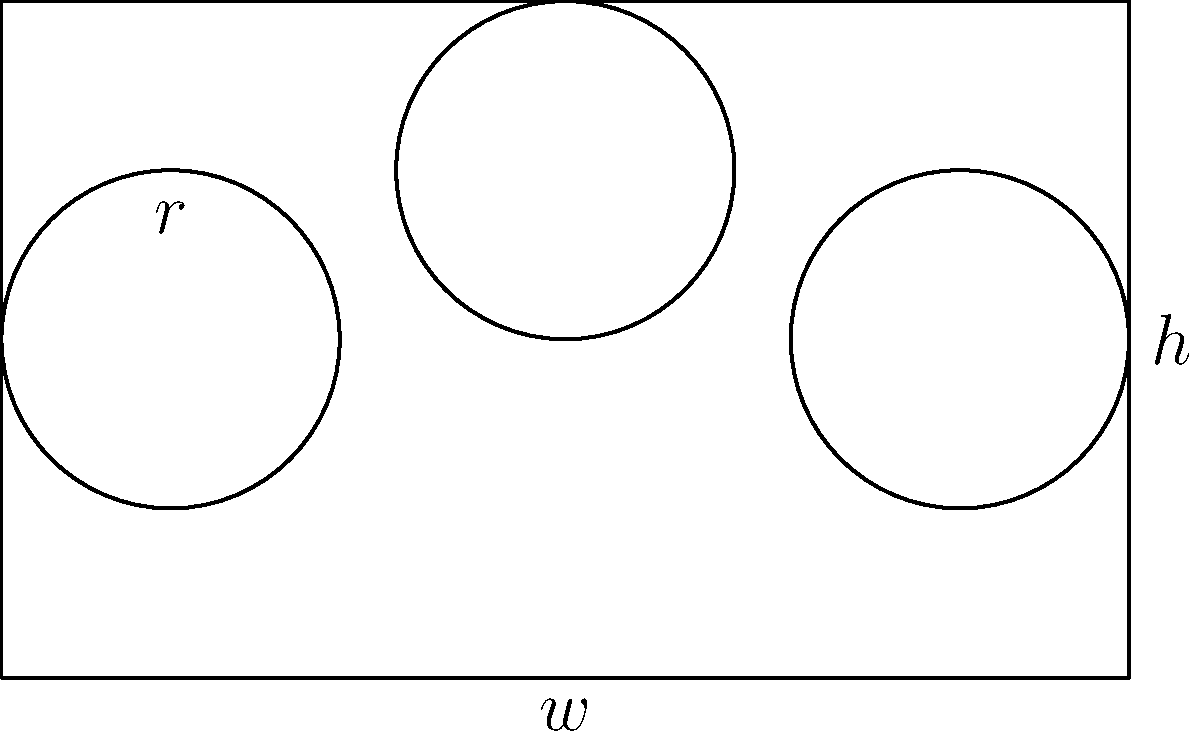As a member of the Fishwatcher Club, you're tasked with designing an aquarium wall with circular viewing windows. The rectangular wall has a width $w$ of 10 meters and a height $h$ of 6 meters. You want to install three identical circular windows with radius $r$ of 1.5 meters. Two windows should be placed at mid-height on the left and right sides of the wall, while the third should be centered horizontally at the top of the wall. What is the total viewing area provided by these windows as a percentage of the entire wall area? Round your answer to the nearest whole percent. Let's approach this step-by-step:

1) First, calculate the area of the rectangular wall:
   $A_{wall} = w \times h = 10 \text{ m} \times 6 \text{ m} = 60 \text{ m}^2$

2) Now, calculate the area of one circular window:
   $A_{window} = \pi r^2 = \pi \times (1.5 \text{ m})^2 = 2.25\pi \text{ m}^2$

3) There are three identical windows, so the total window area is:
   $A_{total\_windows} = 3 \times 2.25\pi \text{ m}^2 = 6.75\pi \text{ m}^2$

4) Convert this to a numerical value:
   $A_{total\_windows} \approx 21.21 \text{ m}^2$

5) Calculate the percentage of the wall covered by windows:
   $\text{Percentage} = \frac{A_{total\_windows}}{A_{wall}} \times 100\%$
   $= \frac{21.21 \text{ m}^2}{60 \text{ m}^2} \times 100\% \approx 35.35\%$

6) Rounding to the nearest whole percent:
   $35.35\% \approx 35\%$
Answer: 35% 